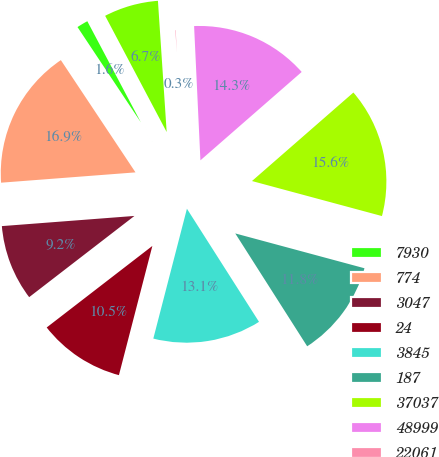Convert chart to OTSL. <chart><loc_0><loc_0><loc_500><loc_500><pie_chart><fcel>7930<fcel>774<fcel>3047<fcel>24<fcel>3845<fcel>187<fcel>37037<fcel>48999<fcel>22061<fcel>3208<nl><fcel>1.59%<fcel>16.88%<fcel>9.24%<fcel>10.51%<fcel>13.06%<fcel>11.78%<fcel>15.61%<fcel>14.33%<fcel>0.31%<fcel>6.69%<nl></chart> 